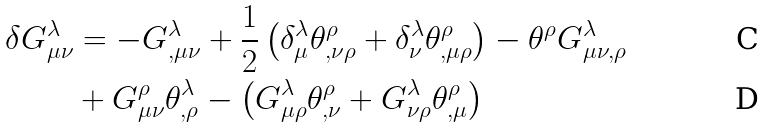<formula> <loc_0><loc_0><loc_500><loc_500>\delta G _ { \mu \nu } ^ { \lambda } & = - G _ { , \mu \nu } ^ { \lambda } + \frac { 1 } { 2 } \left ( \delta _ { \mu } ^ { \lambda } \theta _ { , \nu \rho } ^ { \rho } + \delta _ { \nu } ^ { \lambda } \theta _ { , \mu \rho } ^ { \rho } \right ) - \theta ^ { \rho } G _ { \mu \nu , \rho } ^ { \lambda } \\ & + G _ { \mu \nu } ^ { \rho } \theta _ { , \rho } ^ { \lambda } - \left ( G _ { \mu \rho } ^ { \lambda } \theta _ { , \nu } ^ { \rho } + G _ { \nu \rho } ^ { \lambda } \theta _ { , \mu } ^ { \rho } \right )</formula> 